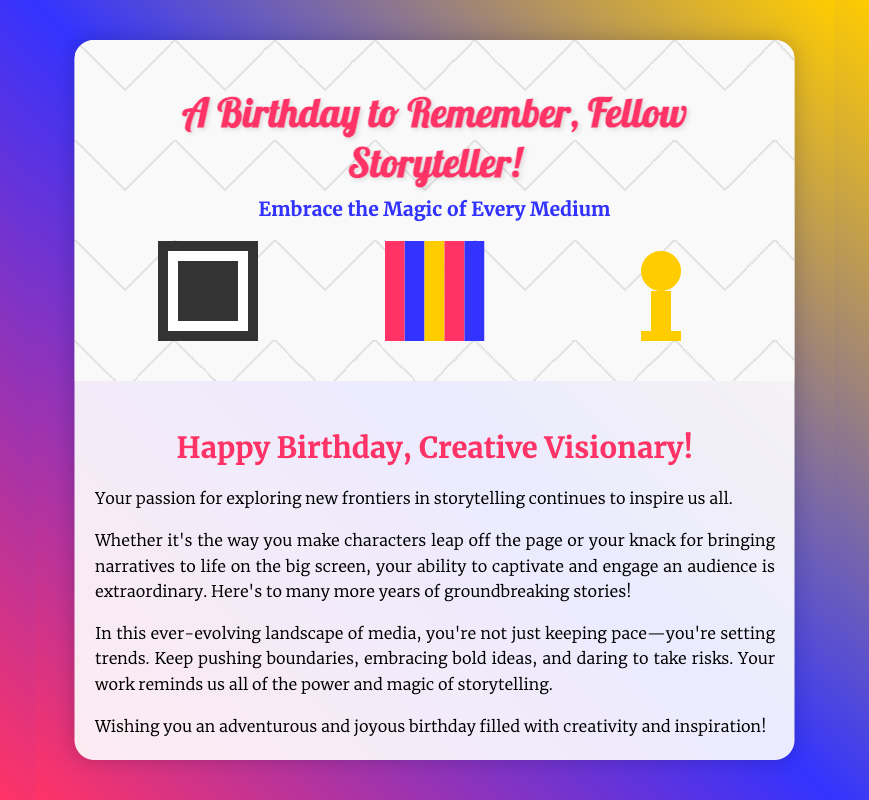What is the main title of the card? The main title is prominently displayed at the top of the card.
Answer: A Birthday to Remember, Fellow Storyteller! What two colors are in the background gradient? The background gradient blends multiple colors, but two prominent ones are noticeable.
Answer: Pink and blue Who is the card addressed to? The message directly addresses the recipient as a "Creative Visionary."
Answer: Creative Visionary What is the first item listed in the inner message? The first sentence of the inner message is a greeting.
Answer: Happy Birthday, Creative Visionary! What motif is prominently used in the imagery section? The imagery showcases three storytelling mediums.
Answer: Film strips, books, and vintage microphones What does the inner message encourage the recipient to do? The phrasing in the inner message emphasizes a particular approach to storytelling.
Answer: Keep pushing boundaries What is the overall theme of the birthday card? The card's message revolves around a specific concept related to storytelling.
Answer: Creativity and inspiration Who is encouraged to take risks? The message conveys encouragement to a particular individual or group.
Answer: The recipient What signature style is used at the bottom of the card? The signature is characterized by a specific format that is customary in greeting cards.
Answer: Italic font 